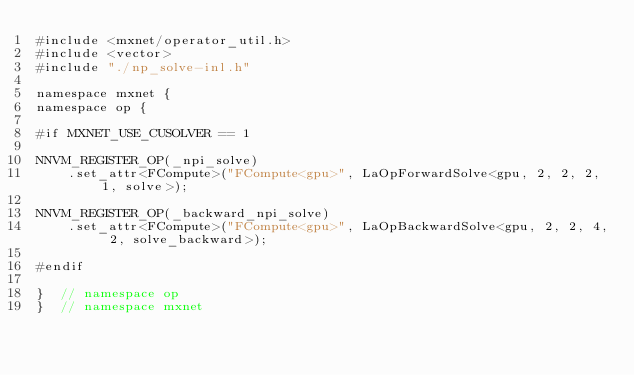<code> <loc_0><loc_0><loc_500><loc_500><_Cuda_>#include <mxnet/operator_util.h>
#include <vector>
#include "./np_solve-inl.h"

namespace mxnet {
namespace op {

#if MXNET_USE_CUSOLVER == 1

NNVM_REGISTER_OP(_npi_solve)
    .set_attr<FCompute>("FCompute<gpu>", LaOpForwardSolve<gpu, 2, 2, 2, 1, solve>);

NNVM_REGISTER_OP(_backward_npi_solve)
    .set_attr<FCompute>("FCompute<gpu>", LaOpBackwardSolve<gpu, 2, 2, 4, 2, solve_backward>);

#endif

}  // namespace op
}  // namespace mxnet
</code> 